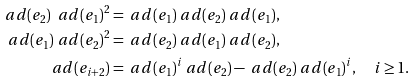<formula> <loc_0><loc_0><loc_500><loc_500>\ a d ( e _ { 2 } ) \ a d ( e _ { 1 } ) ^ { 2 } & = \ a d ( e _ { 1 } ) \ a d ( e _ { 2 } ) \ a d ( e _ { 1 } ) , \\ \ a d ( e _ { 1 } ) \ a d ( e _ { 2 } ) ^ { 2 } & = \ a d ( e _ { 2 } ) \ a d ( e _ { 1 } ) \ a d ( e _ { 2 } ) , \\ \ a d ( e _ { i + 2 } ) & = \ a d ( e _ { 1 } ) ^ { i } \ a d ( e _ { 2 } ) - \ a d ( e _ { 2 } ) \ a d ( e _ { 1 } ) ^ { i } , \quad i \geq 1 .</formula> 